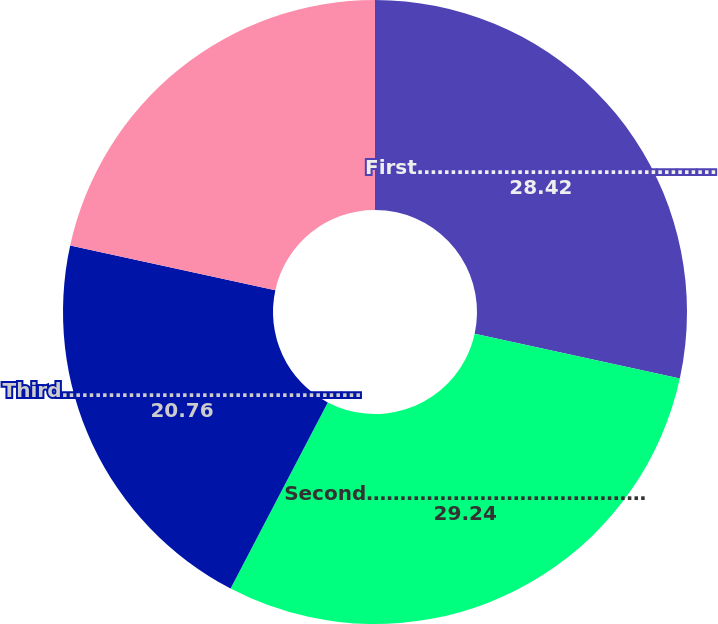Convert chart. <chart><loc_0><loc_0><loc_500><loc_500><pie_chart><fcel>First………………………………………<fcel>Second……………………………………<fcel>Third………………………………………<fcel>Fourth……………………………………<nl><fcel>28.42%<fcel>29.24%<fcel>20.76%<fcel>21.58%<nl></chart> 